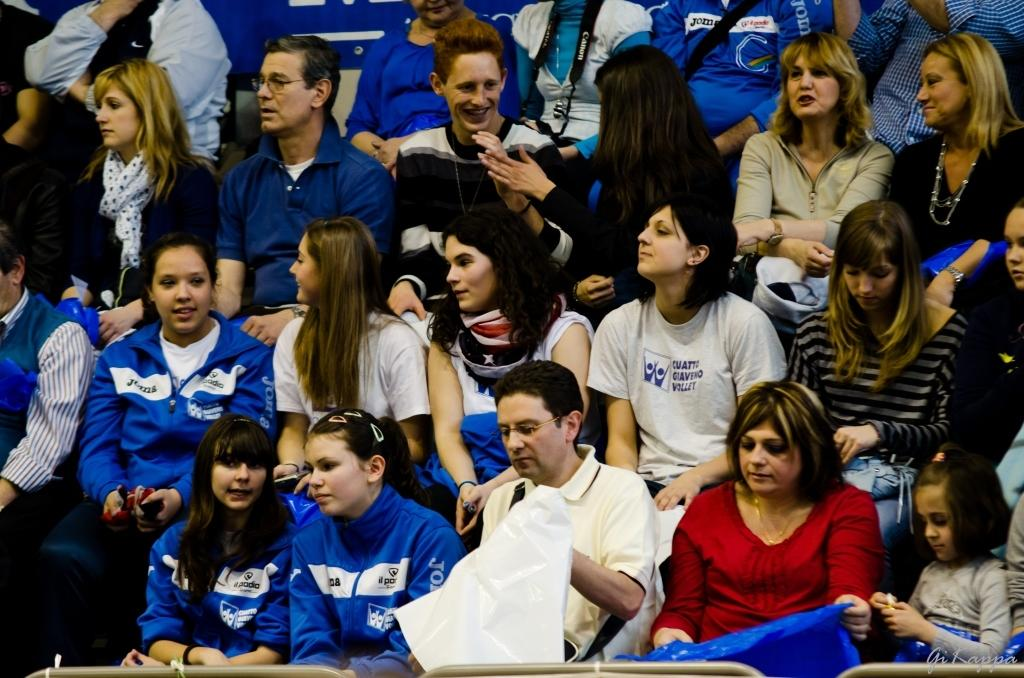What is happening in the image? There is a group of people in the image, and they are sitting. Can you describe the expressions of the people in the image? Some of the people are smiling in the image. What type of brake is being used by the queen in the image? There is no queen or brake present in the image. Can you tell me how many sails are visible in the image? There are no sails visible in the image; it features a group of people sitting. 